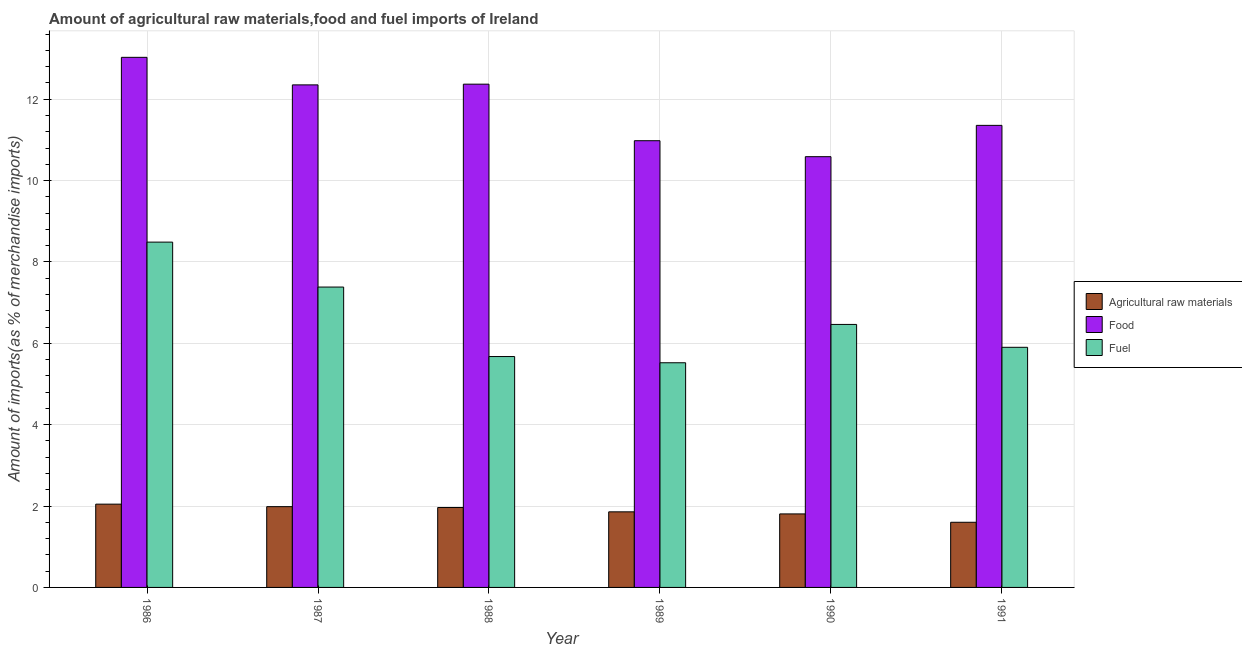How many groups of bars are there?
Offer a terse response. 6. Are the number of bars on each tick of the X-axis equal?
Make the answer very short. Yes. What is the label of the 4th group of bars from the left?
Your answer should be very brief. 1989. In how many cases, is the number of bars for a given year not equal to the number of legend labels?
Your answer should be very brief. 0. What is the percentage of fuel imports in 1989?
Your answer should be very brief. 5.52. Across all years, what is the maximum percentage of fuel imports?
Offer a terse response. 8.49. Across all years, what is the minimum percentage of fuel imports?
Offer a terse response. 5.52. In which year was the percentage of food imports maximum?
Provide a succinct answer. 1986. In which year was the percentage of fuel imports minimum?
Offer a very short reply. 1989. What is the total percentage of raw materials imports in the graph?
Ensure brevity in your answer.  11.26. What is the difference between the percentage of fuel imports in 1986 and that in 1988?
Keep it short and to the point. 2.81. What is the difference between the percentage of raw materials imports in 1988 and the percentage of food imports in 1986?
Give a very brief answer. -0.08. What is the average percentage of raw materials imports per year?
Keep it short and to the point. 1.88. What is the ratio of the percentage of raw materials imports in 1988 to that in 1990?
Keep it short and to the point. 1.09. What is the difference between the highest and the second highest percentage of food imports?
Make the answer very short. 0.66. What is the difference between the highest and the lowest percentage of fuel imports?
Provide a short and direct response. 2.97. What does the 2nd bar from the left in 1989 represents?
Ensure brevity in your answer.  Food. What does the 2nd bar from the right in 1988 represents?
Your answer should be compact. Food. Is it the case that in every year, the sum of the percentage of raw materials imports and percentage of food imports is greater than the percentage of fuel imports?
Make the answer very short. Yes. How many bars are there?
Your response must be concise. 18. What is the difference between two consecutive major ticks on the Y-axis?
Keep it short and to the point. 2. Does the graph contain any zero values?
Provide a succinct answer. No. Does the graph contain grids?
Your answer should be very brief. Yes. How many legend labels are there?
Your answer should be compact. 3. How are the legend labels stacked?
Make the answer very short. Vertical. What is the title of the graph?
Ensure brevity in your answer.  Amount of agricultural raw materials,food and fuel imports of Ireland. Does "Services" appear as one of the legend labels in the graph?
Your answer should be very brief. No. What is the label or title of the X-axis?
Give a very brief answer. Year. What is the label or title of the Y-axis?
Keep it short and to the point. Amount of imports(as % of merchandise imports). What is the Amount of imports(as % of merchandise imports) of Agricultural raw materials in 1986?
Your answer should be very brief. 2.05. What is the Amount of imports(as % of merchandise imports) of Food in 1986?
Provide a short and direct response. 13.03. What is the Amount of imports(as % of merchandise imports) of Fuel in 1986?
Offer a very short reply. 8.49. What is the Amount of imports(as % of merchandise imports) of Agricultural raw materials in 1987?
Keep it short and to the point. 1.99. What is the Amount of imports(as % of merchandise imports) of Food in 1987?
Ensure brevity in your answer.  12.35. What is the Amount of imports(as % of merchandise imports) of Fuel in 1987?
Provide a succinct answer. 7.38. What is the Amount of imports(as % of merchandise imports) of Agricultural raw materials in 1988?
Keep it short and to the point. 1.96. What is the Amount of imports(as % of merchandise imports) of Food in 1988?
Offer a terse response. 12.37. What is the Amount of imports(as % of merchandise imports) in Fuel in 1988?
Your answer should be compact. 5.67. What is the Amount of imports(as % of merchandise imports) in Agricultural raw materials in 1989?
Make the answer very short. 1.86. What is the Amount of imports(as % of merchandise imports) in Food in 1989?
Your response must be concise. 10.98. What is the Amount of imports(as % of merchandise imports) of Fuel in 1989?
Offer a very short reply. 5.52. What is the Amount of imports(as % of merchandise imports) of Agricultural raw materials in 1990?
Your answer should be compact. 1.81. What is the Amount of imports(as % of merchandise imports) in Food in 1990?
Provide a succinct answer. 10.59. What is the Amount of imports(as % of merchandise imports) in Fuel in 1990?
Your answer should be compact. 6.46. What is the Amount of imports(as % of merchandise imports) in Agricultural raw materials in 1991?
Your answer should be very brief. 1.6. What is the Amount of imports(as % of merchandise imports) of Food in 1991?
Your response must be concise. 11.36. What is the Amount of imports(as % of merchandise imports) of Fuel in 1991?
Your answer should be compact. 5.9. Across all years, what is the maximum Amount of imports(as % of merchandise imports) of Agricultural raw materials?
Make the answer very short. 2.05. Across all years, what is the maximum Amount of imports(as % of merchandise imports) in Food?
Offer a terse response. 13.03. Across all years, what is the maximum Amount of imports(as % of merchandise imports) of Fuel?
Provide a short and direct response. 8.49. Across all years, what is the minimum Amount of imports(as % of merchandise imports) in Agricultural raw materials?
Offer a very short reply. 1.6. Across all years, what is the minimum Amount of imports(as % of merchandise imports) of Food?
Offer a very short reply. 10.59. Across all years, what is the minimum Amount of imports(as % of merchandise imports) in Fuel?
Ensure brevity in your answer.  5.52. What is the total Amount of imports(as % of merchandise imports) in Agricultural raw materials in the graph?
Keep it short and to the point. 11.26. What is the total Amount of imports(as % of merchandise imports) of Food in the graph?
Your answer should be compact. 70.67. What is the total Amount of imports(as % of merchandise imports) of Fuel in the graph?
Your answer should be very brief. 39.43. What is the difference between the Amount of imports(as % of merchandise imports) of Agricultural raw materials in 1986 and that in 1987?
Provide a short and direct response. 0.06. What is the difference between the Amount of imports(as % of merchandise imports) of Food in 1986 and that in 1987?
Your response must be concise. 0.68. What is the difference between the Amount of imports(as % of merchandise imports) of Fuel in 1986 and that in 1987?
Your response must be concise. 1.1. What is the difference between the Amount of imports(as % of merchandise imports) of Agricultural raw materials in 1986 and that in 1988?
Provide a succinct answer. 0.08. What is the difference between the Amount of imports(as % of merchandise imports) in Food in 1986 and that in 1988?
Offer a very short reply. 0.66. What is the difference between the Amount of imports(as % of merchandise imports) in Fuel in 1986 and that in 1988?
Ensure brevity in your answer.  2.81. What is the difference between the Amount of imports(as % of merchandise imports) in Agricultural raw materials in 1986 and that in 1989?
Give a very brief answer. 0.19. What is the difference between the Amount of imports(as % of merchandise imports) in Food in 1986 and that in 1989?
Your answer should be compact. 2.05. What is the difference between the Amount of imports(as % of merchandise imports) in Fuel in 1986 and that in 1989?
Make the answer very short. 2.97. What is the difference between the Amount of imports(as % of merchandise imports) in Agricultural raw materials in 1986 and that in 1990?
Offer a very short reply. 0.24. What is the difference between the Amount of imports(as % of merchandise imports) of Food in 1986 and that in 1990?
Your answer should be very brief. 2.44. What is the difference between the Amount of imports(as % of merchandise imports) of Fuel in 1986 and that in 1990?
Offer a very short reply. 2.02. What is the difference between the Amount of imports(as % of merchandise imports) in Agricultural raw materials in 1986 and that in 1991?
Give a very brief answer. 0.45. What is the difference between the Amount of imports(as % of merchandise imports) in Food in 1986 and that in 1991?
Ensure brevity in your answer.  1.67. What is the difference between the Amount of imports(as % of merchandise imports) of Fuel in 1986 and that in 1991?
Provide a short and direct response. 2.59. What is the difference between the Amount of imports(as % of merchandise imports) of Agricultural raw materials in 1987 and that in 1988?
Offer a very short reply. 0.02. What is the difference between the Amount of imports(as % of merchandise imports) of Food in 1987 and that in 1988?
Provide a succinct answer. -0.02. What is the difference between the Amount of imports(as % of merchandise imports) of Fuel in 1987 and that in 1988?
Offer a very short reply. 1.71. What is the difference between the Amount of imports(as % of merchandise imports) in Agricultural raw materials in 1987 and that in 1989?
Make the answer very short. 0.13. What is the difference between the Amount of imports(as % of merchandise imports) of Food in 1987 and that in 1989?
Offer a terse response. 1.37. What is the difference between the Amount of imports(as % of merchandise imports) in Fuel in 1987 and that in 1989?
Your answer should be very brief. 1.86. What is the difference between the Amount of imports(as % of merchandise imports) of Agricultural raw materials in 1987 and that in 1990?
Ensure brevity in your answer.  0.18. What is the difference between the Amount of imports(as % of merchandise imports) of Food in 1987 and that in 1990?
Ensure brevity in your answer.  1.76. What is the difference between the Amount of imports(as % of merchandise imports) in Fuel in 1987 and that in 1990?
Make the answer very short. 0.92. What is the difference between the Amount of imports(as % of merchandise imports) in Agricultural raw materials in 1987 and that in 1991?
Your answer should be very brief. 0.38. What is the difference between the Amount of imports(as % of merchandise imports) in Fuel in 1987 and that in 1991?
Your answer should be compact. 1.48. What is the difference between the Amount of imports(as % of merchandise imports) of Agricultural raw materials in 1988 and that in 1989?
Keep it short and to the point. 0.11. What is the difference between the Amount of imports(as % of merchandise imports) of Food in 1988 and that in 1989?
Offer a very short reply. 1.39. What is the difference between the Amount of imports(as % of merchandise imports) in Fuel in 1988 and that in 1989?
Provide a succinct answer. 0.15. What is the difference between the Amount of imports(as % of merchandise imports) of Agricultural raw materials in 1988 and that in 1990?
Your response must be concise. 0.16. What is the difference between the Amount of imports(as % of merchandise imports) in Food in 1988 and that in 1990?
Provide a succinct answer. 1.78. What is the difference between the Amount of imports(as % of merchandise imports) in Fuel in 1988 and that in 1990?
Provide a succinct answer. -0.79. What is the difference between the Amount of imports(as % of merchandise imports) of Agricultural raw materials in 1988 and that in 1991?
Offer a very short reply. 0.36. What is the difference between the Amount of imports(as % of merchandise imports) in Food in 1988 and that in 1991?
Keep it short and to the point. 1.01. What is the difference between the Amount of imports(as % of merchandise imports) in Fuel in 1988 and that in 1991?
Offer a very short reply. -0.23. What is the difference between the Amount of imports(as % of merchandise imports) in Agricultural raw materials in 1989 and that in 1990?
Provide a succinct answer. 0.05. What is the difference between the Amount of imports(as % of merchandise imports) of Food in 1989 and that in 1990?
Keep it short and to the point. 0.39. What is the difference between the Amount of imports(as % of merchandise imports) in Fuel in 1989 and that in 1990?
Ensure brevity in your answer.  -0.94. What is the difference between the Amount of imports(as % of merchandise imports) of Agricultural raw materials in 1989 and that in 1991?
Provide a short and direct response. 0.26. What is the difference between the Amount of imports(as % of merchandise imports) of Food in 1989 and that in 1991?
Give a very brief answer. -0.38. What is the difference between the Amount of imports(as % of merchandise imports) of Fuel in 1989 and that in 1991?
Your answer should be very brief. -0.38. What is the difference between the Amount of imports(as % of merchandise imports) in Agricultural raw materials in 1990 and that in 1991?
Give a very brief answer. 0.21. What is the difference between the Amount of imports(as % of merchandise imports) in Food in 1990 and that in 1991?
Ensure brevity in your answer.  -0.77. What is the difference between the Amount of imports(as % of merchandise imports) of Fuel in 1990 and that in 1991?
Give a very brief answer. 0.56. What is the difference between the Amount of imports(as % of merchandise imports) of Agricultural raw materials in 1986 and the Amount of imports(as % of merchandise imports) of Food in 1987?
Provide a short and direct response. -10.3. What is the difference between the Amount of imports(as % of merchandise imports) of Agricultural raw materials in 1986 and the Amount of imports(as % of merchandise imports) of Fuel in 1987?
Your answer should be very brief. -5.34. What is the difference between the Amount of imports(as % of merchandise imports) of Food in 1986 and the Amount of imports(as % of merchandise imports) of Fuel in 1987?
Your answer should be very brief. 5.65. What is the difference between the Amount of imports(as % of merchandise imports) in Agricultural raw materials in 1986 and the Amount of imports(as % of merchandise imports) in Food in 1988?
Your response must be concise. -10.32. What is the difference between the Amount of imports(as % of merchandise imports) in Agricultural raw materials in 1986 and the Amount of imports(as % of merchandise imports) in Fuel in 1988?
Keep it short and to the point. -3.63. What is the difference between the Amount of imports(as % of merchandise imports) in Food in 1986 and the Amount of imports(as % of merchandise imports) in Fuel in 1988?
Ensure brevity in your answer.  7.35. What is the difference between the Amount of imports(as % of merchandise imports) of Agricultural raw materials in 1986 and the Amount of imports(as % of merchandise imports) of Food in 1989?
Your answer should be very brief. -8.93. What is the difference between the Amount of imports(as % of merchandise imports) of Agricultural raw materials in 1986 and the Amount of imports(as % of merchandise imports) of Fuel in 1989?
Your answer should be very brief. -3.48. What is the difference between the Amount of imports(as % of merchandise imports) in Food in 1986 and the Amount of imports(as % of merchandise imports) in Fuel in 1989?
Provide a succinct answer. 7.51. What is the difference between the Amount of imports(as % of merchandise imports) of Agricultural raw materials in 1986 and the Amount of imports(as % of merchandise imports) of Food in 1990?
Make the answer very short. -8.54. What is the difference between the Amount of imports(as % of merchandise imports) of Agricultural raw materials in 1986 and the Amount of imports(as % of merchandise imports) of Fuel in 1990?
Provide a succinct answer. -4.42. What is the difference between the Amount of imports(as % of merchandise imports) of Food in 1986 and the Amount of imports(as % of merchandise imports) of Fuel in 1990?
Make the answer very short. 6.56. What is the difference between the Amount of imports(as % of merchandise imports) of Agricultural raw materials in 1986 and the Amount of imports(as % of merchandise imports) of Food in 1991?
Ensure brevity in your answer.  -9.31. What is the difference between the Amount of imports(as % of merchandise imports) of Agricultural raw materials in 1986 and the Amount of imports(as % of merchandise imports) of Fuel in 1991?
Give a very brief answer. -3.85. What is the difference between the Amount of imports(as % of merchandise imports) in Food in 1986 and the Amount of imports(as % of merchandise imports) in Fuel in 1991?
Keep it short and to the point. 7.13. What is the difference between the Amount of imports(as % of merchandise imports) in Agricultural raw materials in 1987 and the Amount of imports(as % of merchandise imports) in Food in 1988?
Offer a terse response. -10.38. What is the difference between the Amount of imports(as % of merchandise imports) in Agricultural raw materials in 1987 and the Amount of imports(as % of merchandise imports) in Fuel in 1988?
Provide a short and direct response. -3.69. What is the difference between the Amount of imports(as % of merchandise imports) in Food in 1987 and the Amount of imports(as % of merchandise imports) in Fuel in 1988?
Provide a succinct answer. 6.68. What is the difference between the Amount of imports(as % of merchandise imports) in Agricultural raw materials in 1987 and the Amount of imports(as % of merchandise imports) in Food in 1989?
Ensure brevity in your answer.  -8.99. What is the difference between the Amount of imports(as % of merchandise imports) of Agricultural raw materials in 1987 and the Amount of imports(as % of merchandise imports) of Fuel in 1989?
Make the answer very short. -3.54. What is the difference between the Amount of imports(as % of merchandise imports) in Food in 1987 and the Amount of imports(as % of merchandise imports) in Fuel in 1989?
Your answer should be very brief. 6.83. What is the difference between the Amount of imports(as % of merchandise imports) of Agricultural raw materials in 1987 and the Amount of imports(as % of merchandise imports) of Food in 1990?
Provide a short and direct response. -8.6. What is the difference between the Amount of imports(as % of merchandise imports) of Agricultural raw materials in 1987 and the Amount of imports(as % of merchandise imports) of Fuel in 1990?
Offer a terse response. -4.48. What is the difference between the Amount of imports(as % of merchandise imports) in Food in 1987 and the Amount of imports(as % of merchandise imports) in Fuel in 1990?
Offer a terse response. 5.89. What is the difference between the Amount of imports(as % of merchandise imports) of Agricultural raw materials in 1987 and the Amount of imports(as % of merchandise imports) of Food in 1991?
Offer a terse response. -9.37. What is the difference between the Amount of imports(as % of merchandise imports) of Agricultural raw materials in 1987 and the Amount of imports(as % of merchandise imports) of Fuel in 1991?
Keep it short and to the point. -3.92. What is the difference between the Amount of imports(as % of merchandise imports) of Food in 1987 and the Amount of imports(as % of merchandise imports) of Fuel in 1991?
Your answer should be compact. 6.45. What is the difference between the Amount of imports(as % of merchandise imports) of Agricultural raw materials in 1988 and the Amount of imports(as % of merchandise imports) of Food in 1989?
Your answer should be very brief. -9.02. What is the difference between the Amount of imports(as % of merchandise imports) of Agricultural raw materials in 1988 and the Amount of imports(as % of merchandise imports) of Fuel in 1989?
Keep it short and to the point. -3.56. What is the difference between the Amount of imports(as % of merchandise imports) of Food in 1988 and the Amount of imports(as % of merchandise imports) of Fuel in 1989?
Ensure brevity in your answer.  6.85. What is the difference between the Amount of imports(as % of merchandise imports) of Agricultural raw materials in 1988 and the Amount of imports(as % of merchandise imports) of Food in 1990?
Provide a succinct answer. -8.62. What is the difference between the Amount of imports(as % of merchandise imports) of Agricultural raw materials in 1988 and the Amount of imports(as % of merchandise imports) of Fuel in 1990?
Your answer should be very brief. -4.5. What is the difference between the Amount of imports(as % of merchandise imports) of Food in 1988 and the Amount of imports(as % of merchandise imports) of Fuel in 1990?
Keep it short and to the point. 5.91. What is the difference between the Amount of imports(as % of merchandise imports) of Agricultural raw materials in 1988 and the Amount of imports(as % of merchandise imports) of Food in 1991?
Your answer should be compact. -9.39. What is the difference between the Amount of imports(as % of merchandise imports) in Agricultural raw materials in 1988 and the Amount of imports(as % of merchandise imports) in Fuel in 1991?
Make the answer very short. -3.94. What is the difference between the Amount of imports(as % of merchandise imports) of Food in 1988 and the Amount of imports(as % of merchandise imports) of Fuel in 1991?
Make the answer very short. 6.47. What is the difference between the Amount of imports(as % of merchandise imports) in Agricultural raw materials in 1989 and the Amount of imports(as % of merchandise imports) in Food in 1990?
Your response must be concise. -8.73. What is the difference between the Amount of imports(as % of merchandise imports) in Agricultural raw materials in 1989 and the Amount of imports(as % of merchandise imports) in Fuel in 1990?
Your answer should be compact. -4.61. What is the difference between the Amount of imports(as % of merchandise imports) in Food in 1989 and the Amount of imports(as % of merchandise imports) in Fuel in 1990?
Your answer should be compact. 4.52. What is the difference between the Amount of imports(as % of merchandise imports) of Agricultural raw materials in 1989 and the Amount of imports(as % of merchandise imports) of Food in 1991?
Keep it short and to the point. -9.5. What is the difference between the Amount of imports(as % of merchandise imports) in Agricultural raw materials in 1989 and the Amount of imports(as % of merchandise imports) in Fuel in 1991?
Offer a very short reply. -4.04. What is the difference between the Amount of imports(as % of merchandise imports) in Food in 1989 and the Amount of imports(as % of merchandise imports) in Fuel in 1991?
Your response must be concise. 5.08. What is the difference between the Amount of imports(as % of merchandise imports) of Agricultural raw materials in 1990 and the Amount of imports(as % of merchandise imports) of Food in 1991?
Keep it short and to the point. -9.55. What is the difference between the Amount of imports(as % of merchandise imports) in Agricultural raw materials in 1990 and the Amount of imports(as % of merchandise imports) in Fuel in 1991?
Make the answer very short. -4.09. What is the difference between the Amount of imports(as % of merchandise imports) of Food in 1990 and the Amount of imports(as % of merchandise imports) of Fuel in 1991?
Offer a terse response. 4.69. What is the average Amount of imports(as % of merchandise imports) of Agricultural raw materials per year?
Keep it short and to the point. 1.88. What is the average Amount of imports(as % of merchandise imports) of Food per year?
Ensure brevity in your answer.  11.78. What is the average Amount of imports(as % of merchandise imports) in Fuel per year?
Provide a short and direct response. 6.57. In the year 1986, what is the difference between the Amount of imports(as % of merchandise imports) in Agricultural raw materials and Amount of imports(as % of merchandise imports) in Food?
Your answer should be very brief. -10.98. In the year 1986, what is the difference between the Amount of imports(as % of merchandise imports) in Agricultural raw materials and Amount of imports(as % of merchandise imports) in Fuel?
Keep it short and to the point. -6.44. In the year 1986, what is the difference between the Amount of imports(as % of merchandise imports) of Food and Amount of imports(as % of merchandise imports) of Fuel?
Give a very brief answer. 4.54. In the year 1987, what is the difference between the Amount of imports(as % of merchandise imports) in Agricultural raw materials and Amount of imports(as % of merchandise imports) in Food?
Provide a short and direct response. -10.37. In the year 1987, what is the difference between the Amount of imports(as % of merchandise imports) in Agricultural raw materials and Amount of imports(as % of merchandise imports) in Fuel?
Give a very brief answer. -5.4. In the year 1987, what is the difference between the Amount of imports(as % of merchandise imports) in Food and Amount of imports(as % of merchandise imports) in Fuel?
Provide a short and direct response. 4.97. In the year 1988, what is the difference between the Amount of imports(as % of merchandise imports) in Agricultural raw materials and Amount of imports(as % of merchandise imports) in Food?
Your response must be concise. -10.41. In the year 1988, what is the difference between the Amount of imports(as % of merchandise imports) of Agricultural raw materials and Amount of imports(as % of merchandise imports) of Fuel?
Give a very brief answer. -3.71. In the year 1988, what is the difference between the Amount of imports(as % of merchandise imports) in Food and Amount of imports(as % of merchandise imports) in Fuel?
Ensure brevity in your answer.  6.69. In the year 1989, what is the difference between the Amount of imports(as % of merchandise imports) in Agricultural raw materials and Amount of imports(as % of merchandise imports) in Food?
Give a very brief answer. -9.12. In the year 1989, what is the difference between the Amount of imports(as % of merchandise imports) of Agricultural raw materials and Amount of imports(as % of merchandise imports) of Fuel?
Provide a succinct answer. -3.66. In the year 1989, what is the difference between the Amount of imports(as % of merchandise imports) of Food and Amount of imports(as % of merchandise imports) of Fuel?
Make the answer very short. 5.46. In the year 1990, what is the difference between the Amount of imports(as % of merchandise imports) of Agricultural raw materials and Amount of imports(as % of merchandise imports) of Food?
Keep it short and to the point. -8.78. In the year 1990, what is the difference between the Amount of imports(as % of merchandise imports) in Agricultural raw materials and Amount of imports(as % of merchandise imports) in Fuel?
Make the answer very short. -4.66. In the year 1990, what is the difference between the Amount of imports(as % of merchandise imports) of Food and Amount of imports(as % of merchandise imports) of Fuel?
Offer a terse response. 4.12. In the year 1991, what is the difference between the Amount of imports(as % of merchandise imports) of Agricultural raw materials and Amount of imports(as % of merchandise imports) of Food?
Give a very brief answer. -9.76. In the year 1991, what is the difference between the Amount of imports(as % of merchandise imports) in Agricultural raw materials and Amount of imports(as % of merchandise imports) in Fuel?
Make the answer very short. -4.3. In the year 1991, what is the difference between the Amount of imports(as % of merchandise imports) of Food and Amount of imports(as % of merchandise imports) of Fuel?
Give a very brief answer. 5.45. What is the ratio of the Amount of imports(as % of merchandise imports) in Agricultural raw materials in 1986 to that in 1987?
Offer a terse response. 1.03. What is the ratio of the Amount of imports(as % of merchandise imports) in Food in 1986 to that in 1987?
Give a very brief answer. 1.05. What is the ratio of the Amount of imports(as % of merchandise imports) of Fuel in 1986 to that in 1987?
Make the answer very short. 1.15. What is the ratio of the Amount of imports(as % of merchandise imports) in Agricultural raw materials in 1986 to that in 1988?
Your answer should be very brief. 1.04. What is the ratio of the Amount of imports(as % of merchandise imports) in Food in 1986 to that in 1988?
Your answer should be compact. 1.05. What is the ratio of the Amount of imports(as % of merchandise imports) of Fuel in 1986 to that in 1988?
Provide a short and direct response. 1.5. What is the ratio of the Amount of imports(as % of merchandise imports) of Agricultural raw materials in 1986 to that in 1989?
Provide a short and direct response. 1.1. What is the ratio of the Amount of imports(as % of merchandise imports) in Food in 1986 to that in 1989?
Keep it short and to the point. 1.19. What is the ratio of the Amount of imports(as % of merchandise imports) in Fuel in 1986 to that in 1989?
Ensure brevity in your answer.  1.54. What is the ratio of the Amount of imports(as % of merchandise imports) in Agricultural raw materials in 1986 to that in 1990?
Provide a short and direct response. 1.13. What is the ratio of the Amount of imports(as % of merchandise imports) of Food in 1986 to that in 1990?
Your response must be concise. 1.23. What is the ratio of the Amount of imports(as % of merchandise imports) in Fuel in 1986 to that in 1990?
Ensure brevity in your answer.  1.31. What is the ratio of the Amount of imports(as % of merchandise imports) in Agricultural raw materials in 1986 to that in 1991?
Give a very brief answer. 1.28. What is the ratio of the Amount of imports(as % of merchandise imports) in Food in 1986 to that in 1991?
Your response must be concise. 1.15. What is the ratio of the Amount of imports(as % of merchandise imports) in Fuel in 1986 to that in 1991?
Your answer should be very brief. 1.44. What is the ratio of the Amount of imports(as % of merchandise imports) of Agricultural raw materials in 1987 to that in 1988?
Offer a very short reply. 1.01. What is the ratio of the Amount of imports(as % of merchandise imports) of Food in 1987 to that in 1988?
Your answer should be compact. 1. What is the ratio of the Amount of imports(as % of merchandise imports) in Fuel in 1987 to that in 1988?
Offer a very short reply. 1.3. What is the ratio of the Amount of imports(as % of merchandise imports) of Agricultural raw materials in 1987 to that in 1989?
Provide a short and direct response. 1.07. What is the ratio of the Amount of imports(as % of merchandise imports) in Food in 1987 to that in 1989?
Make the answer very short. 1.12. What is the ratio of the Amount of imports(as % of merchandise imports) in Fuel in 1987 to that in 1989?
Your answer should be compact. 1.34. What is the ratio of the Amount of imports(as % of merchandise imports) in Agricultural raw materials in 1987 to that in 1990?
Ensure brevity in your answer.  1.1. What is the ratio of the Amount of imports(as % of merchandise imports) in Fuel in 1987 to that in 1990?
Provide a short and direct response. 1.14. What is the ratio of the Amount of imports(as % of merchandise imports) in Agricultural raw materials in 1987 to that in 1991?
Offer a terse response. 1.24. What is the ratio of the Amount of imports(as % of merchandise imports) of Food in 1987 to that in 1991?
Ensure brevity in your answer.  1.09. What is the ratio of the Amount of imports(as % of merchandise imports) of Fuel in 1987 to that in 1991?
Keep it short and to the point. 1.25. What is the ratio of the Amount of imports(as % of merchandise imports) of Agricultural raw materials in 1988 to that in 1989?
Ensure brevity in your answer.  1.06. What is the ratio of the Amount of imports(as % of merchandise imports) in Food in 1988 to that in 1989?
Your answer should be compact. 1.13. What is the ratio of the Amount of imports(as % of merchandise imports) of Fuel in 1988 to that in 1989?
Make the answer very short. 1.03. What is the ratio of the Amount of imports(as % of merchandise imports) in Agricultural raw materials in 1988 to that in 1990?
Give a very brief answer. 1.09. What is the ratio of the Amount of imports(as % of merchandise imports) in Food in 1988 to that in 1990?
Your response must be concise. 1.17. What is the ratio of the Amount of imports(as % of merchandise imports) in Fuel in 1988 to that in 1990?
Provide a succinct answer. 0.88. What is the ratio of the Amount of imports(as % of merchandise imports) in Agricultural raw materials in 1988 to that in 1991?
Keep it short and to the point. 1.23. What is the ratio of the Amount of imports(as % of merchandise imports) of Food in 1988 to that in 1991?
Your response must be concise. 1.09. What is the ratio of the Amount of imports(as % of merchandise imports) of Fuel in 1988 to that in 1991?
Provide a succinct answer. 0.96. What is the ratio of the Amount of imports(as % of merchandise imports) in Agricultural raw materials in 1989 to that in 1990?
Your answer should be very brief. 1.03. What is the ratio of the Amount of imports(as % of merchandise imports) of Fuel in 1989 to that in 1990?
Offer a very short reply. 0.85. What is the ratio of the Amount of imports(as % of merchandise imports) of Agricultural raw materials in 1989 to that in 1991?
Provide a succinct answer. 1.16. What is the ratio of the Amount of imports(as % of merchandise imports) in Food in 1989 to that in 1991?
Your answer should be compact. 0.97. What is the ratio of the Amount of imports(as % of merchandise imports) in Fuel in 1989 to that in 1991?
Provide a succinct answer. 0.94. What is the ratio of the Amount of imports(as % of merchandise imports) in Agricultural raw materials in 1990 to that in 1991?
Your response must be concise. 1.13. What is the ratio of the Amount of imports(as % of merchandise imports) in Food in 1990 to that in 1991?
Make the answer very short. 0.93. What is the ratio of the Amount of imports(as % of merchandise imports) in Fuel in 1990 to that in 1991?
Provide a succinct answer. 1.1. What is the difference between the highest and the second highest Amount of imports(as % of merchandise imports) in Agricultural raw materials?
Make the answer very short. 0.06. What is the difference between the highest and the second highest Amount of imports(as % of merchandise imports) of Food?
Your answer should be compact. 0.66. What is the difference between the highest and the second highest Amount of imports(as % of merchandise imports) in Fuel?
Your answer should be very brief. 1.1. What is the difference between the highest and the lowest Amount of imports(as % of merchandise imports) of Agricultural raw materials?
Provide a short and direct response. 0.45. What is the difference between the highest and the lowest Amount of imports(as % of merchandise imports) of Food?
Provide a short and direct response. 2.44. What is the difference between the highest and the lowest Amount of imports(as % of merchandise imports) of Fuel?
Offer a terse response. 2.97. 